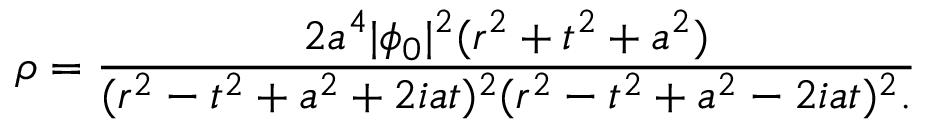<formula> <loc_0><loc_0><loc_500><loc_500>\rho = { \frac { 2 a ^ { 4 } | \phi _ { 0 } | ^ { 2 } ( r ^ { 2 } + t ^ { 2 } + a ^ { 2 } ) } { ( r ^ { 2 } - t ^ { 2 } + a ^ { 2 } + 2 i a t ) ^ { 2 } ( r ^ { 2 } - t ^ { 2 } + a ^ { 2 } - 2 i a t ) ^ { 2 } . } }</formula> 